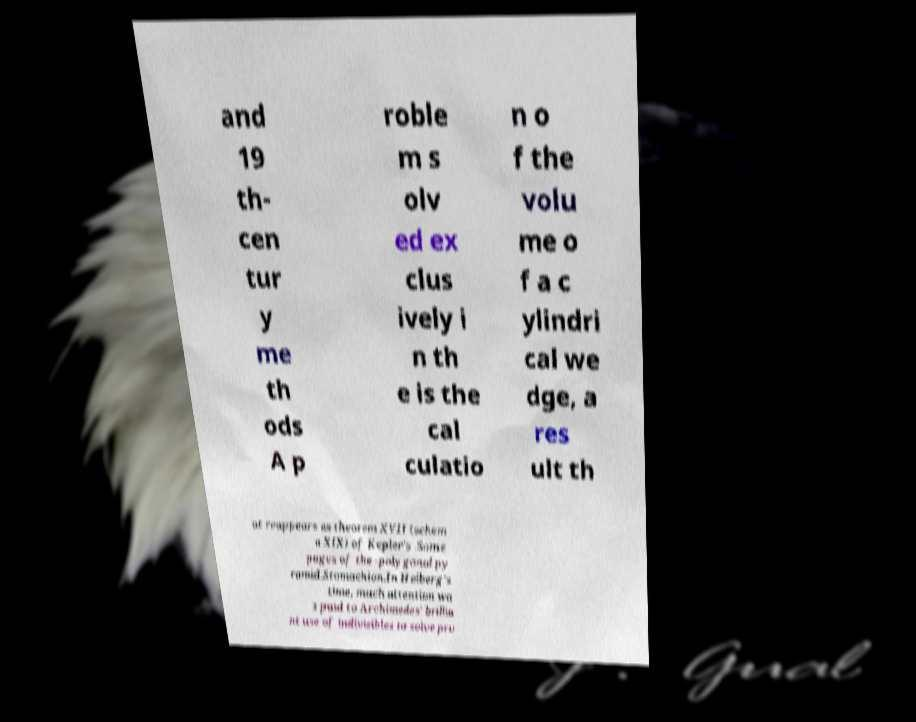Can you read and provide the text displayed in the image?This photo seems to have some interesting text. Can you extract and type it out for me? and 19 th- cen tur y me th ods A p roble m s olv ed ex clus ively i n th e is the cal culatio n o f the volu me o f a c ylindri cal we dge, a res ult th at reappears as theorem XVII (schem a XIX) of Kepler's .Some pages of the -polygonal py ramid.Stomachion.In Heiberg's time, much attention wa s paid to Archimedes' brillia nt use of indivisibles to solve pro 